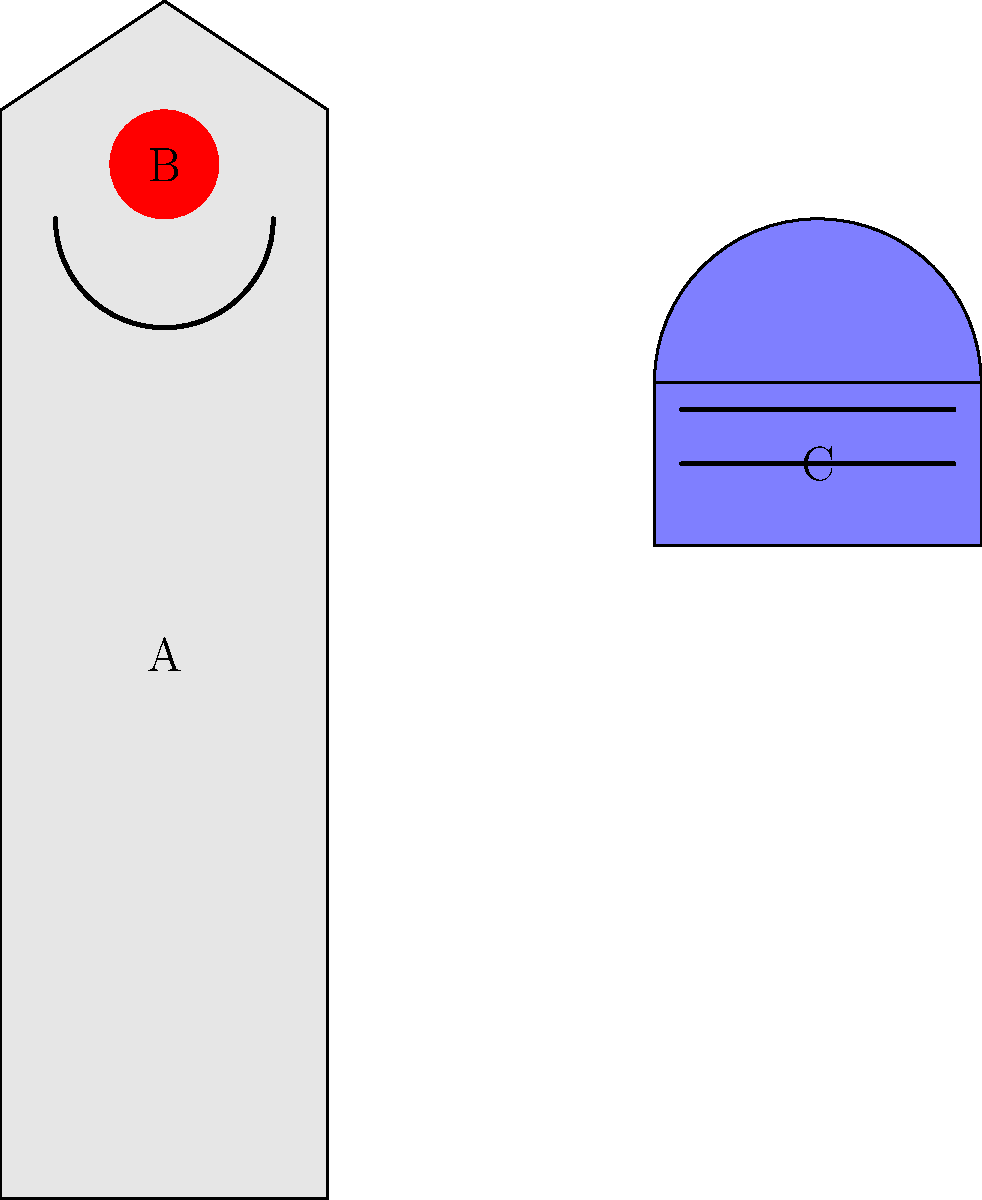In the diagram above, three key components of women's lacrosse equipment are labeled A, B, and C. According to NCAA regulations, which of these components has the most stringent size restrictions, and what is the maximum allowable dimension for this component? To answer this question, we need to consider the NCAA regulations for each component:

1. Component A (Lacrosse stick):
   - The overall length must be between 35.5 and 43.25 inches.
   - The head width must be between 7 and 9 inches at its widest point.

2. Component B (Ball):
   - The ball must have a circumference between 7.75 and 8 inches.
   - The ball must weigh between 5 and 5.25 ounces.

3. Component C (Helmet):
   - Helmets are not mandatory in women's lacrosse, but when used, they must meet ASTM standards.
   - There are no specific size restrictions for helmets in women's lacrosse.

Comparing these regulations:

- The stick (A) has a range of 7.75 inches for length and 2 inches for head width.
- The ball (B) has a very narrow range of 0.25 inches for circumference and 0.25 ounces for weight.
- The helmet (C) has no specific size restrictions.

The ball (B) has the most stringent size restrictions, with only a 0.25-inch range for its circumference.

To calculate the maximum allowable dimension:
Maximum circumference = 8 inches
Diameter = Circumference / π
Diameter = 8 / π ≈ 2.55 inches

Therefore, the maximum allowable dimension for the ball is its diameter, approximately 2.55 inches.
Answer: Ball (B); 2.55 inches (diameter) 